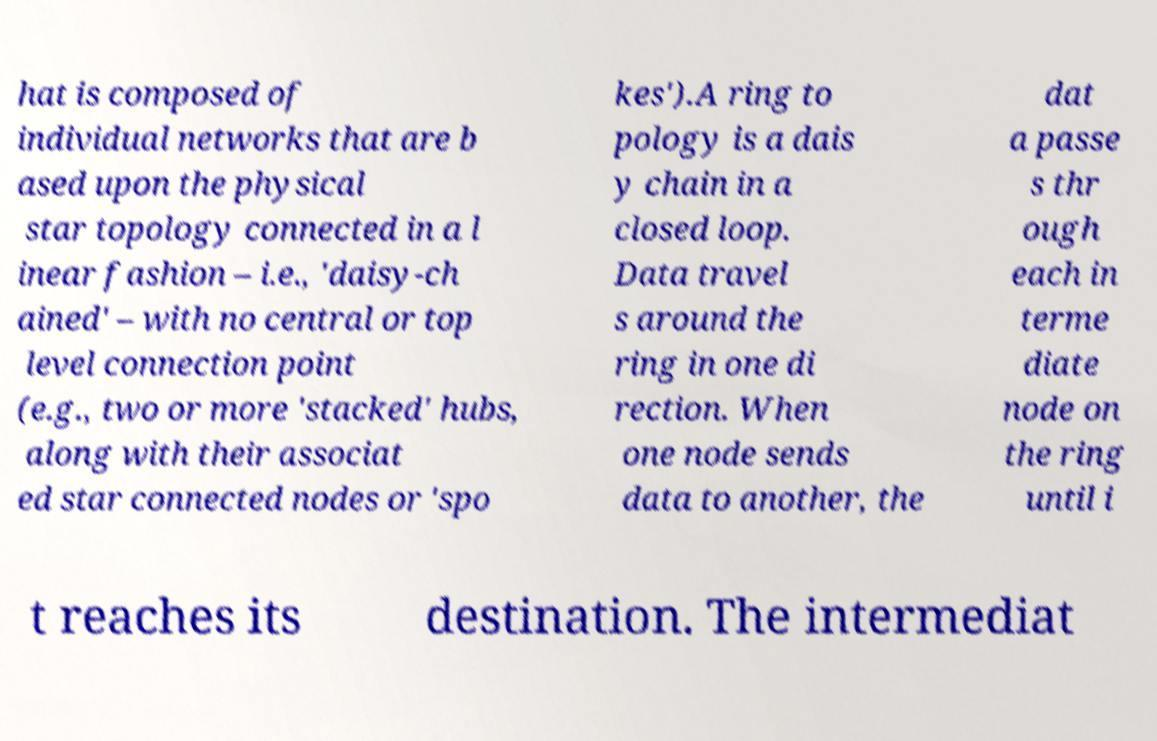For documentation purposes, I need the text within this image transcribed. Could you provide that? hat is composed of individual networks that are b ased upon the physical star topology connected in a l inear fashion – i.e., 'daisy-ch ained' – with no central or top level connection point (e.g., two or more 'stacked' hubs, along with their associat ed star connected nodes or 'spo kes').A ring to pology is a dais y chain in a closed loop. Data travel s around the ring in one di rection. When one node sends data to another, the dat a passe s thr ough each in terme diate node on the ring until i t reaches its destination. The intermediat 